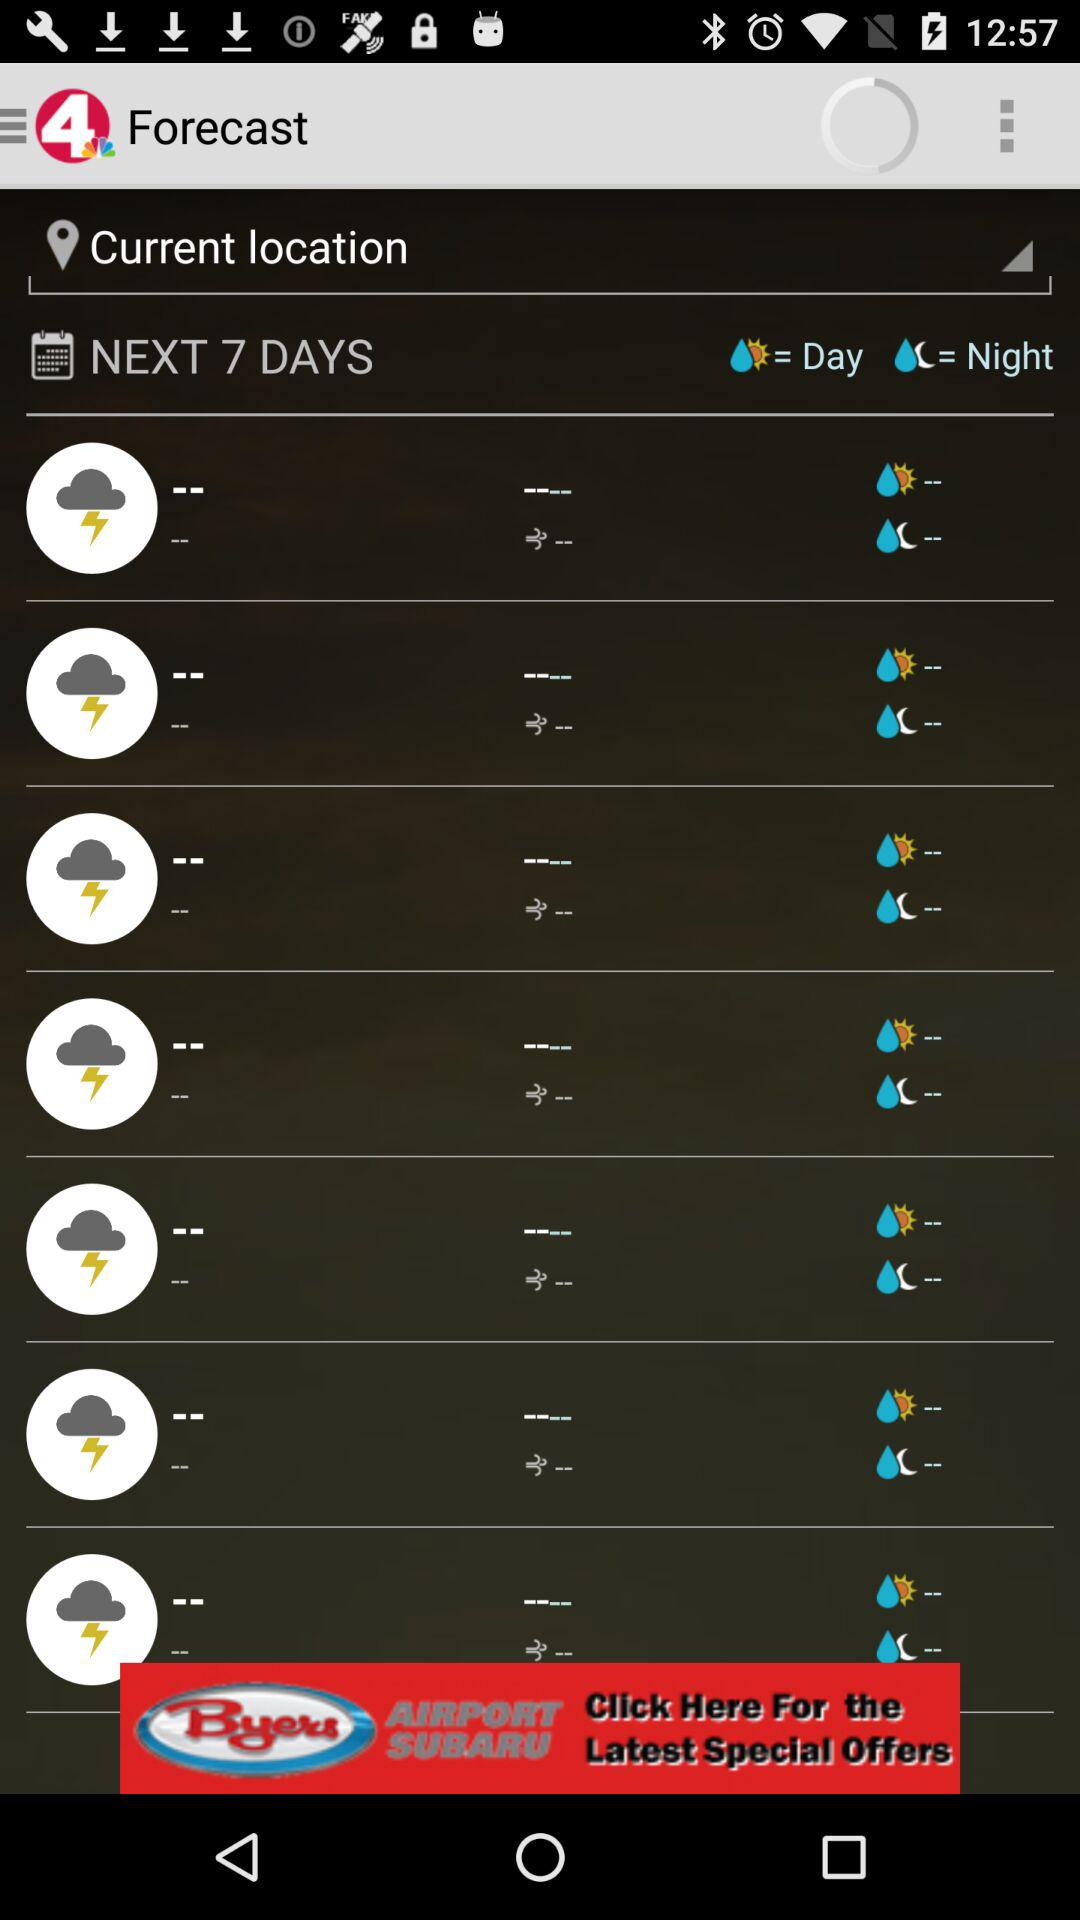How many next days forecast? It is for next 7 days. 